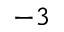<formula> <loc_0><loc_0><loc_500><loc_500>^ { - 3 }</formula> 